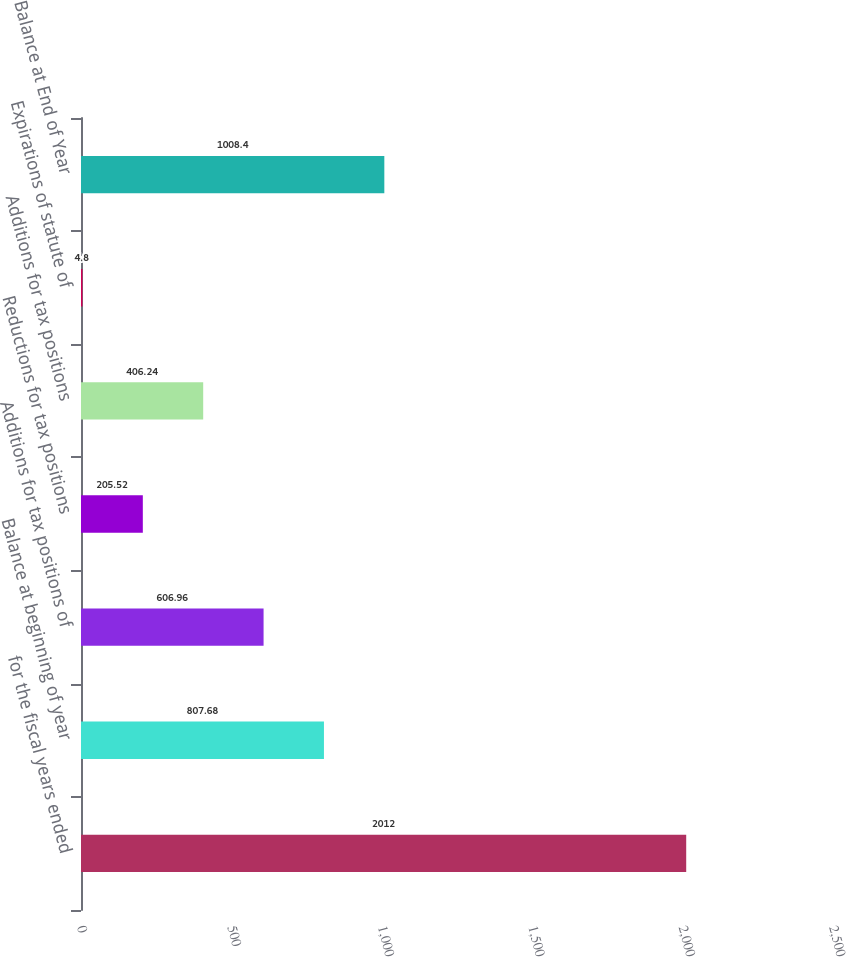Convert chart. <chart><loc_0><loc_0><loc_500><loc_500><bar_chart><fcel>for the fiscal years ended<fcel>Balance at beginning of year<fcel>Additions for tax positions of<fcel>Reductions for tax positions<fcel>Additions for tax positions<fcel>Expirations of statute of<fcel>Balance at End of Year<nl><fcel>2012<fcel>807.68<fcel>606.96<fcel>205.52<fcel>406.24<fcel>4.8<fcel>1008.4<nl></chart> 